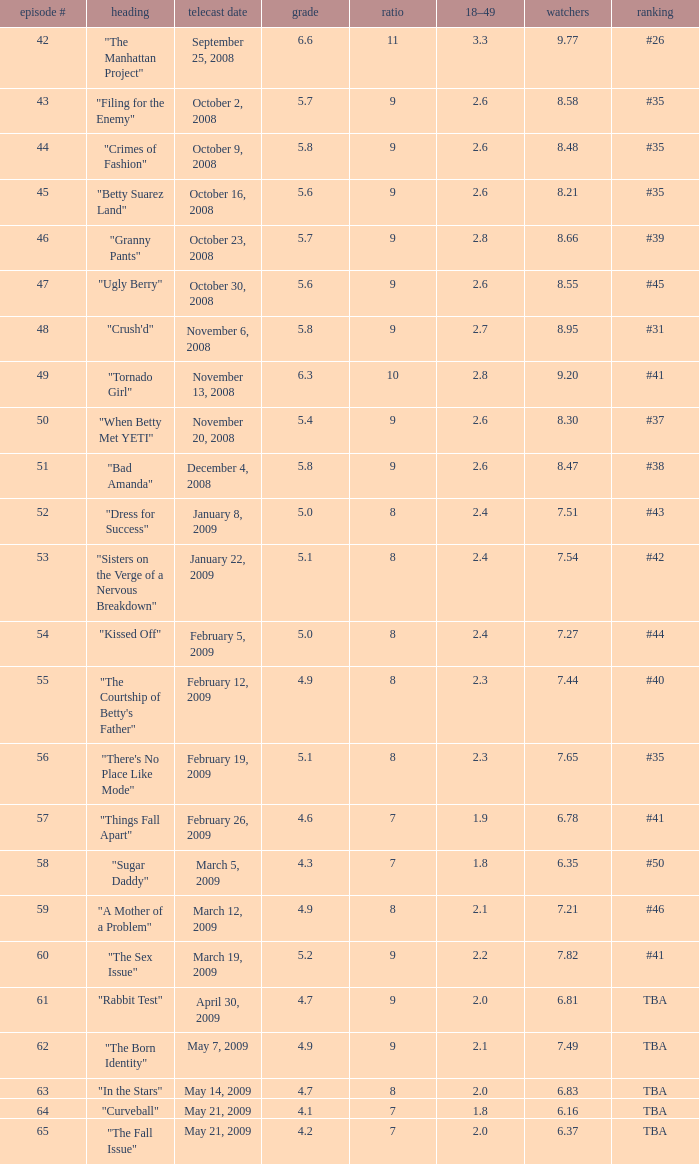Give me the full table as a dictionary. {'header': ['episode #', 'heading', 'telecast date', 'grade', 'ratio', '18–49', 'watchers', 'ranking'], 'rows': [['42', '"The Manhattan Project"', 'September 25, 2008', '6.6', '11', '3.3', '9.77', '#26'], ['43', '"Filing for the Enemy"', 'October 2, 2008', '5.7', '9', '2.6', '8.58', '#35'], ['44', '"Crimes of Fashion"', 'October 9, 2008', '5.8', '9', '2.6', '8.48', '#35'], ['45', '"Betty Suarez Land"', 'October 16, 2008', '5.6', '9', '2.6', '8.21', '#35'], ['46', '"Granny Pants"', 'October 23, 2008', '5.7', '9', '2.8', '8.66', '#39'], ['47', '"Ugly Berry"', 'October 30, 2008', '5.6', '9', '2.6', '8.55', '#45'], ['48', '"Crush\'d"', 'November 6, 2008', '5.8', '9', '2.7', '8.95', '#31'], ['49', '"Tornado Girl"', 'November 13, 2008', '6.3', '10', '2.8', '9.20', '#41'], ['50', '"When Betty Met YETI"', 'November 20, 2008', '5.4', '9', '2.6', '8.30', '#37'], ['51', '"Bad Amanda"', 'December 4, 2008', '5.8', '9', '2.6', '8.47', '#38'], ['52', '"Dress for Success"', 'January 8, 2009', '5.0', '8', '2.4', '7.51', '#43'], ['53', '"Sisters on the Verge of a Nervous Breakdown"', 'January 22, 2009', '5.1', '8', '2.4', '7.54', '#42'], ['54', '"Kissed Off"', 'February 5, 2009', '5.0', '8', '2.4', '7.27', '#44'], ['55', '"The Courtship of Betty\'s Father"', 'February 12, 2009', '4.9', '8', '2.3', '7.44', '#40'], ['56', '"There\'s No Place Like Mode"', 'February 19, 2009', '5.1', '8', '2.3', '7.65', '#35'], ['57', '"Things Fall Apart"', 'February 26, 2009', '4.6', '7', '1.9', '6.78', '#41'], ['58', '"Sugar Daddy"', 'March 5, 2009', '4.3', '7', '1.8', '6.35', '#50'], ['59', '"A Mother of a Problem"', 'March 12, 2009', '4.9', '8', '2.1', '7.21', '#46'], ['60', '"The Sex Issue"', 'March 19, 2009', '5.2', '9', '2.2', '7.82', '#41'], ['61', '"Rabbit Test"', 'April 30, 2009', '4.7', '9', '2.0', '6.81', 'TBA'], ['62', '"The Born Identity"', 'May 7, 2009', '4.9', '9', '2.1', '7.49', 'TBA'], ['63', '"In the Stars"', 'May 14, 2009', '4.7', '8', '2.0', '6.83', 'TBA'], ['64', '"Curveball"', 'May 21, 2009', '4.1', '7', '1.8', '6.16', 'TBA'], ['65', '"The Fall Issue"', 'May 21, 2009', '4.2', '7', '2.0', '6.37', 'TBA']]} What is the average Episode # with a 7 share and 18–49 is less than 2 and the Air Date of may 21, 2009? 64.0. 